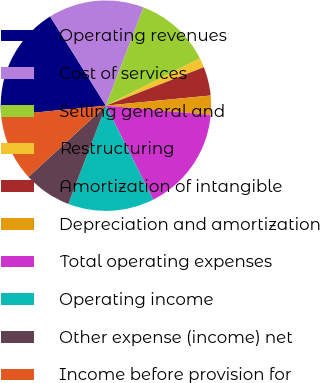Convert chart to OTSL. <chart><loc_0><loc_0><loc_500><loc_500><pie_chart><fcel>Operating revenues<fcel>Cost of services<fcel>Selling general and<fcel>Restructuring<fcel>Amortization of intangible<fcel>Depreciation and amortization<fcel>Total operating expenses<fcel>Operating income<fcel>Other expense (income) net<fcel>Income before provision for<nl><fcel>17.65%<fcel>14.71%<fcel>11.76%<fcel>1.47%<fcel>4.41%<fcel>2.94%<fcel>16.18%<fcel>13.24%<fcel>7.35%<fcel>10.29%<nl></chart> 